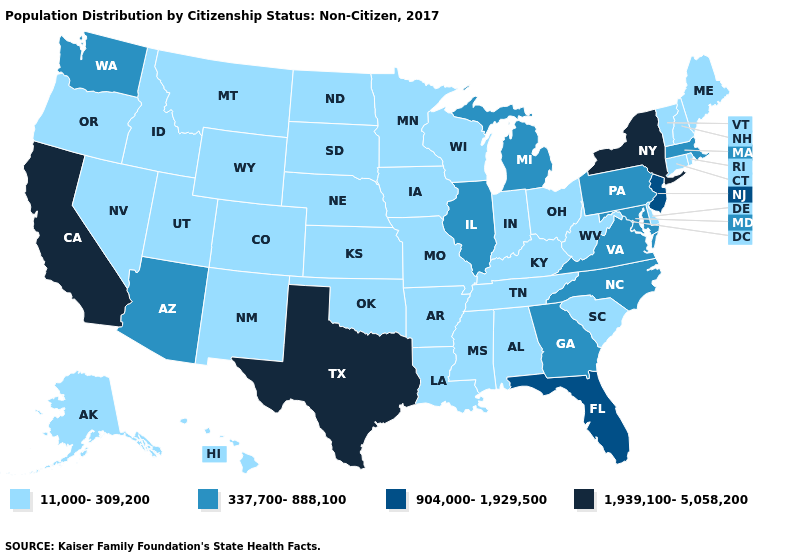Name the states that have a value in the range 1,939,100-5,058,200?
Quick response, please. California, New York, Texas. Does the first symbol in the legend represent the smallest category?
Quick response, please. Yes. Name the states that have a value in the range 337,700-888,100?
Answer briefly. Arizona, Georgia, Illinois, Maryland, Massachusetts, Michigan, North Carolina, Pennsylvania, Virginia, Washington. What is the lowest value in the Northeast?
Short answer required. 11,000-309,200. What is the lowest value in the Northeast?
Give a very brief answer. 11,000-309,200. Does Louisiana have a higher value than Maine?
Be succinct. No. Among the states that border Louisiana , does Texas have the lowest value?
Keep it brief. No. Among the states that border New Jersey , which have the lowest value?
Keep it brief. Delaware. Does New Mexico have a lower value than Massachusetts?
Keep it brief. Yes. What is the value of Georgia?
Concise answer only. 337,700-888,100. What is the highest value in the South ?
Quick response, please. 1,939,100-5,058,200. Does New York have the same value as Maine?
Quick response, please. No. Which states have the lowest value in the USA?
Short answer required. Alabama, Alaska, Arkansas, Colorado, Connecticut, Delaware, Hawaii, Idaho, Indiana, Iowa, Kansas, Kentucky, Louisiana, Maine, Minnesota, Mississippi, Missouri, Montana, Nebraska, Nevada, New Hampshire, New Mexico, North Dakota, Ohio, Oklahoma, Oregon, Rhode Island, South Carolina, South Dakota, Tennessee, Utah, Vermont, West Virginia, Wisconsin, Wyoming. Name the states that have a value in the range 904,000-1,929,500?
Short answer required. Florida, New Jersey. 